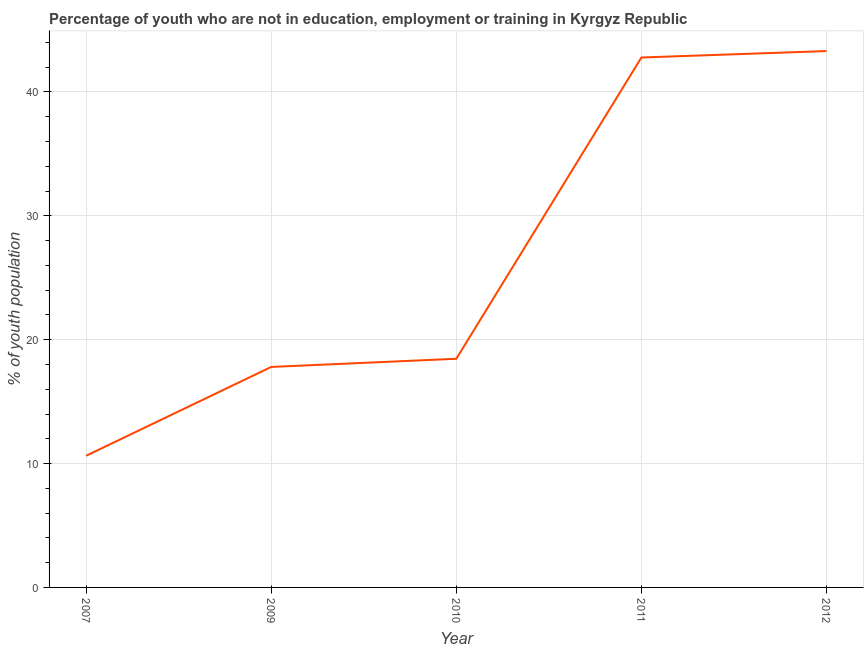What is the unemployed youth population in 2007?
Provide a succinct answer. 10.63. Across all years, what is the maximum unemployed youth population?
Keep it short and to the point. 43.3. Across all years, what is the minimum unemployed youth population?
Keep it short and to the point. 10.63. In which year was the unemployed youth population maximum?
Your answer should be compact. 2012. In which year was the unemployed youth population minimum?
Provide a short and direct response. 2007. What is the sum of the unemployed youth population?
Make the answer very short. 132.97. What is the difference between the unemployed youth population in 2009 and 2012?
Your answer should be very brief. -25.5. What is the average unemployed youth population per year?
Make the answer very short. 26.59. What is the median unemployed youth population?
Provide a short and direct response. 18.46. In how many years, is the unemployed youth population greater than 14 %?
Give a very brief answer. 4. Do a majority of the years between 2012 and 2007 (inclusive) have unemployed youth population greater than 16 %?
Offer a very short reply. Yes. What is the ratio of the unemployed youth population in 2007 to that in 2010?
Your answer should be very brief. 0.58. Is the unemployed youth population in 2009 less than that in 2012?
Offer a very short reply. Yes. What is the difference between the highest and the second highest unemployed youth population?
Offer a terse response. 0.52. Is the sum of the unemployed youth population in 2010 and 2012 greater than the maximum unemployed youth population across all years?
Provide a short and direct response. Yes. What is the difference between the highest and the lowest unemployed youth population?
Provide a short and direct response. 32.67. Does the unemployed youth population monotonically increase over the years?
Make the answer very short. Yes. How many lines are there?
Ensure brevity in your answer.  1. What is the difference between two consecutive major ticks on the Y-axis?
Provide a short and direct response. 10. Does the graph contain grids?
Give a very brief answer. Yes. What is the title of the graph?
Your answer should be very brief. Percentage of youth who are not in education, employment or training in Kyrgyz Republic. What is the label or title of the X-axis?
Ensure brevity in your answer.  Year. What is the label or title of the Y-axis?
Give a very brief answer. % of youth population. What is the % of youth population of 2007?
Give a very brief answer. 10.63. What is the % of youth population in 2009?
Offer a terse response. 17.8. What is the % of youth population of 2010?
Your response must be concise. 18.46. What is the % of youth population in 2011?
Give a very brief answer. 42.78. What is the % of youth population of 2012?
Provide a succinct answer. 43.3. What is the difference between the % of youth population in 2007 and 2009?
Keep it short and to the point. -7.17. What is the difference between the % of youth population in 2007 and 2010?
Ensure brevity in your answer.  -7.83. What is the difference between the % of youth population in 2007 and 2011?
Provide a short and direct response. -32.15. What is the difference between the % of youth population in 2007 and 2012?
Offer a very short reply. -32.67. What is the difference between the % of youth population in 2009 and 2010?
Your answer should be very brief. -0.66. What is the difference between the % of youth population in 2009 and 2011?
Make the answer very short. -24.98. What is the difference between the % of youth population in 2009 and 2012?
Your response must be concise. -25.5. What is the difference between the % of youth population in 2010 and 2011?
Offer a very short reply. -24.32. What is the difference between the % of youth population in 2010 and 2012?
Provide a succinct answer. -24.84. What is the difference between the % of youth population in 2011 and 2012?
Provide a succinct answer. -0.52. What is the ratio of the % of youth population in 2007 to that in 2009?
Keep it short and to the point. 0.6. What is the ratio of the % of youth population in 2007 to that in 2010?
Offer a very short reply. 0.58. What is the ratio of the % of youth population in 2007 to that in 2011?
Your response must be concise. 0.25. What is the ratio of the % of youth population in 2007 to that in 2012?
Offer a terse response. 0.24. What is the ratio of the % of youth population in 2009 to that in 2011?
Offer a terse response. 0.42. What is the ratio of the % of youth population in 2009 to that in 2012?
Ensure brevity in your answer.  0.41. What is the ratio of the % of youth population in 2010 to that in 2011?
Provide a short and direct response. 0.43. What is the ratio of the % of youth population in 2010 to that in 2012?
Provide a succinct answer. 0.43. 